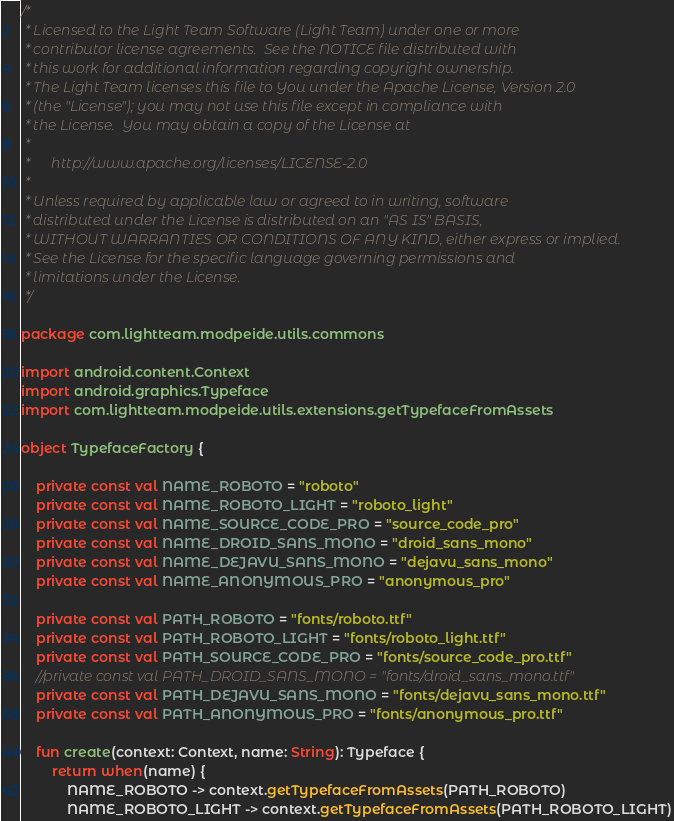<code> <loc_0><loc_0><loc_500><loc_500><_Kotlin_>/*
 * Licensed to the Light Team Software (Light Team) under one or more
 * contributor license agreements.  See the NOTICE file distributed with
 * this work for additional information regarding copyright ownership.
 * The Light Team licenses this file to You under the Apache License, Version 2.0
 * (the "License"); you may not use this file except in compliance with
 * the License.  You may obtain a copy of the License at
 *
 *      http://www.apache.org/licenses/LICENSE-2.0
 *
 * Unless required by applicable law or agreed to in writing, software
 * distributed under the License is distributed on an "AS IS" BASIS,
 * WITHOUT WARRANTIES OR CONDITIONS OF ANY KIND, either express or implied.
 * See the License for the specific language governing permissions and
 * limitations under the License.
 */

package com.lightteam.modpeide.utils.commons

import android.content.Context
import android.graphics.Typeface
import com.lightteam.modpeide.utils.extensions.getTypefaceFromAssets

object TypefaceFactory {

    private const val NAME_ROBOTO = "roboto"
    private const val NAME_ROBOTO_LIGHT = "roboto_light"
    private const val NAME_SOURCE_CODE_PRO = "source_code_pro"
    private const val NAME_DROID_SANS_MONO = "droid_sans_mono"
    private const val NAME_DEJAVU_SANS_MONO = "dejavu_sans_mono"
    private const val NAME_ANONYMOUS_PRO = "anonymous_pro"

    private const val PATH_ROBOTO = "fonts/roboto.ttf"
    private const val PATH_ROBOTO_LIGHT = "fonts/roboto_light.ttf"
    private const val PATH_SOURCE_CODE_PRO = "fonts/source_code_pro.ttf"
    //private const val PATH_DROID_SANS_MONO = "fonts/droid_sans_mono.ttf"
    private const val PATH_DEJAVU_SANS_MONO = "fonts/dejavu_sans_mono.ttf"
    private const val PATH_ANONYMOUS_PRO = "fonts/anonymous_pro.ttf"

    fun create(context: Context, name: String): Typeface {
        return when(name) {
            NAME_ROBOTO -> context.getTypefaceFromAssets(PATH_ROBOTO)
            NAME_ROBOTO_LIGHT -> context.getTypefaceFromAssets(PATH_ROBOTO_LIGHT)</code> 